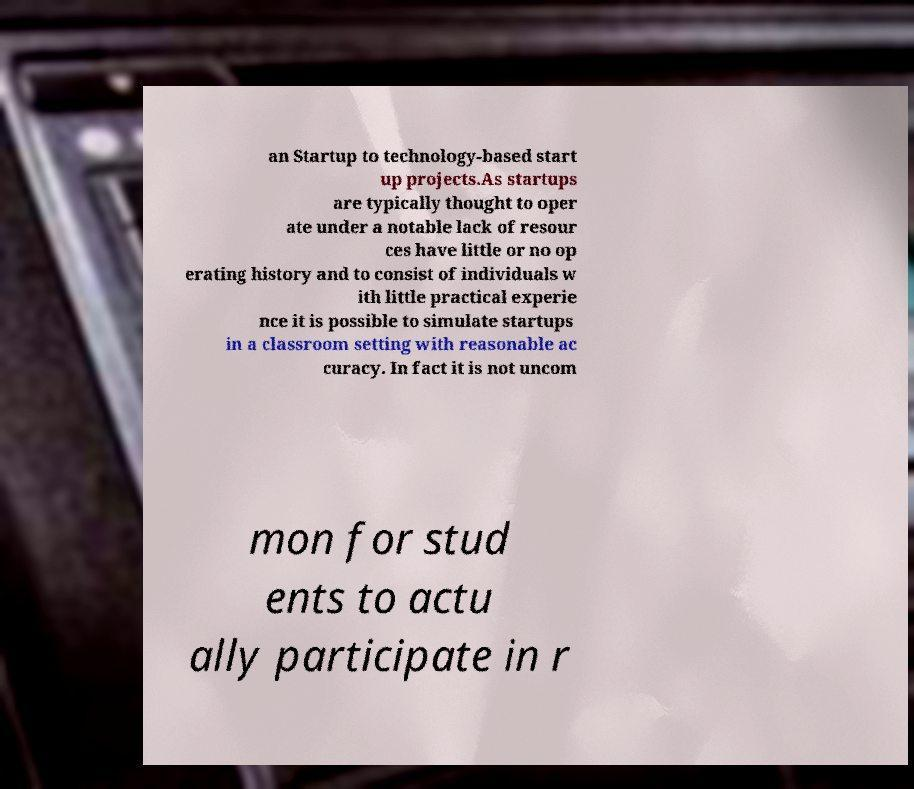I need the written content from this picture converted into text. Can you do that? an Startup to technology-based start up projects.As startups are typically thought to oper ate under a notable lack of resour ces have little or no op erating history and to consist of individuals w ith little practical experie nce it is possible to simulate startups in a classroom setting with reasonable ac curacy. In fact it is not uncom mon for stud ents to actu ally participate in r 